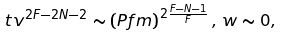<formula> <loc_0><loc_0><loc_500><loc_500>t v ^ { 2 F - 2 N - 2 } \sim \left ( P f m \right ) ^ { 2 \frac { F - N - 1 } { F } } , \, w \sim 0 ,</formula> 